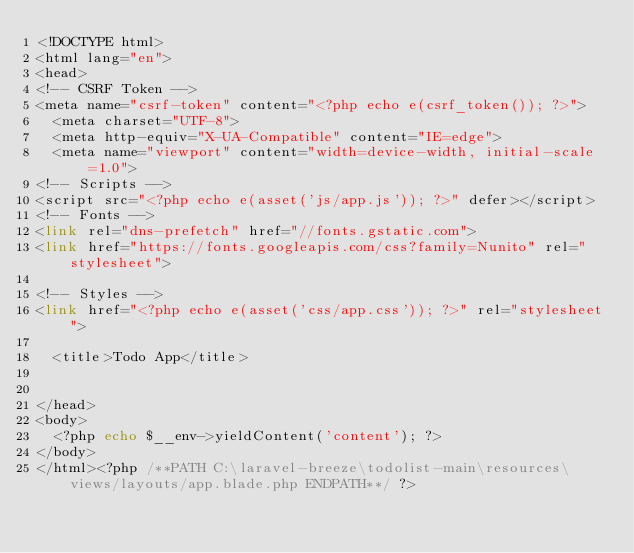<code> <loc_0><loc_0><loc_500><loc_500><_PHP_><!DOCTYPE html>
<html lang="en">
<head>
<!-- CSRF Token -->
<meta name="csrf-token" content="<?php echo e(csrf_token()); ?>">
  <meta charset="UTF-8">
  <meta http-equiv="X-UA-Compatible" content="IE=edge">
  <meta name="viewport" content="width=device-width, initial-scale=1.0">
<!-- Scripts -->
<script src="<?php echo e(asset('js/app.js')); ?>" defer></script>
<!-- Fonts -->
<link rel="dns-prefetch" href="//fonts.gstatic.com">
<link href="https://fonts.googleapis.com/css?family=Nunito" rel="stylesheet">

<!-- Styles -->
<link href="<?php echo e(asset('css/app.css')); ?>" rel="stylesheet">

  <title>Todo App</title>


</head>
<body>
  <?php echo $__env->yieldContent('content'); ?>
</body>
</html><?php /**PATH C:\laravel-breeze\todolist-main\resources\views/layouts/app.blade.php ENDPATH**/ ?></code> 